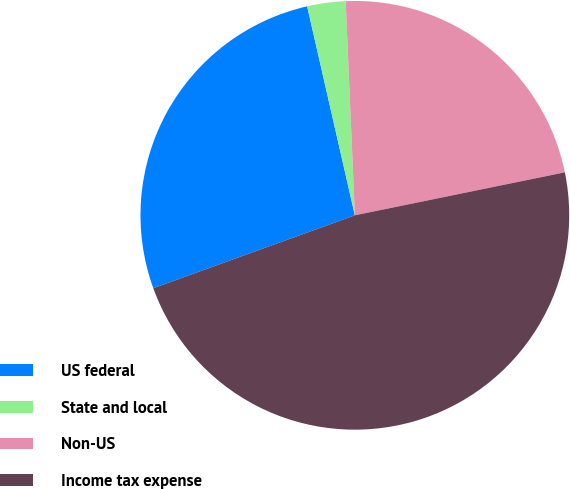<chart> <loc_0><loc_0><loc_500><loc_500><pie_chart><fcel>US federal<fcel>State and local<fcel>Non-US<fcel>Income tax expense<nl><fcel>26.95%<fcel>2.89%<fcel>22.47%<fcel>47.69%<nl></chart> 